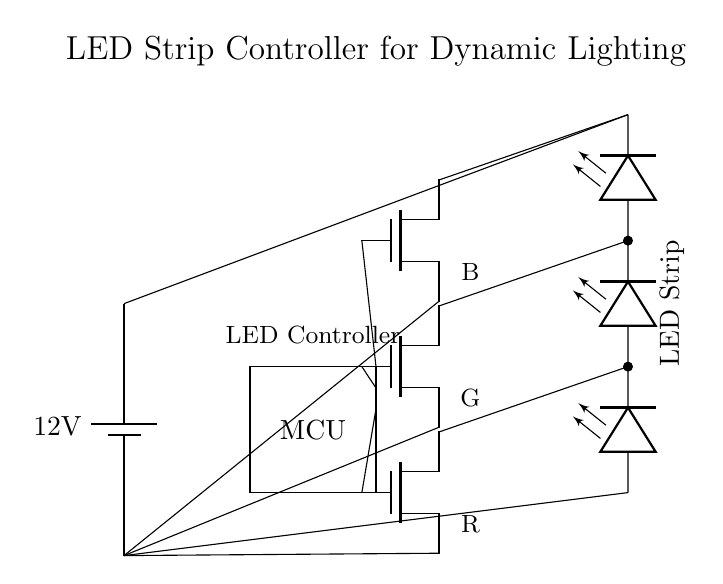What is the voltage of the power supply? The circuit diagram shows a battery labeled with a voltage of 12 volts, which indicates the potential difference provided by the power supply.
Answer: 12 volts How many MOSFET drivers are in the circuit? The circuit diagram depicts three n-channel MOSFET devices that serve as drivers for controlling the LED strip's colors, indicating the number of MOSFET drivers.
Answer: Three What does the microcontroller do in this circuit? The microcontroller (MCU) is responsible for sending control signals to the gates of the MOSFETs, which regulate the power supplied to the LED strip based on programmed lighting effects.
Answer: Control signals Which colors can the LED strip display based on this circuit? The circuit shows three MOSFETs labeled R, G, and B, indicating that the LED strip can display colors red, green, and blue by mixing these colors.
Answer: Red, Green, Blue What is the purpose of using n-channel MOSFETs in this circuit? N-channel MOSFETs are used for low-side switching, providing an efficient way to control the current through the LED strip by applying voltage to the gate. This allows for better thermal management and switching performance.
Answer: Control current What can happen if the voltage is higher than 12 volts? Exceeding 12 volts can lead to excessive current flowing through the components, potentially damaging the LED strip, the MOSFETs, and even the microcontroller due to heat buildup and overvoltage conditions.
Answer: Damage What type of circuit is this? This circuit is a driver circuit specifically designed for controlling LED strips, which provides dynamic lighting effects, making it suitable for applications in performances and entertainment.
Answer: Driver circuit 